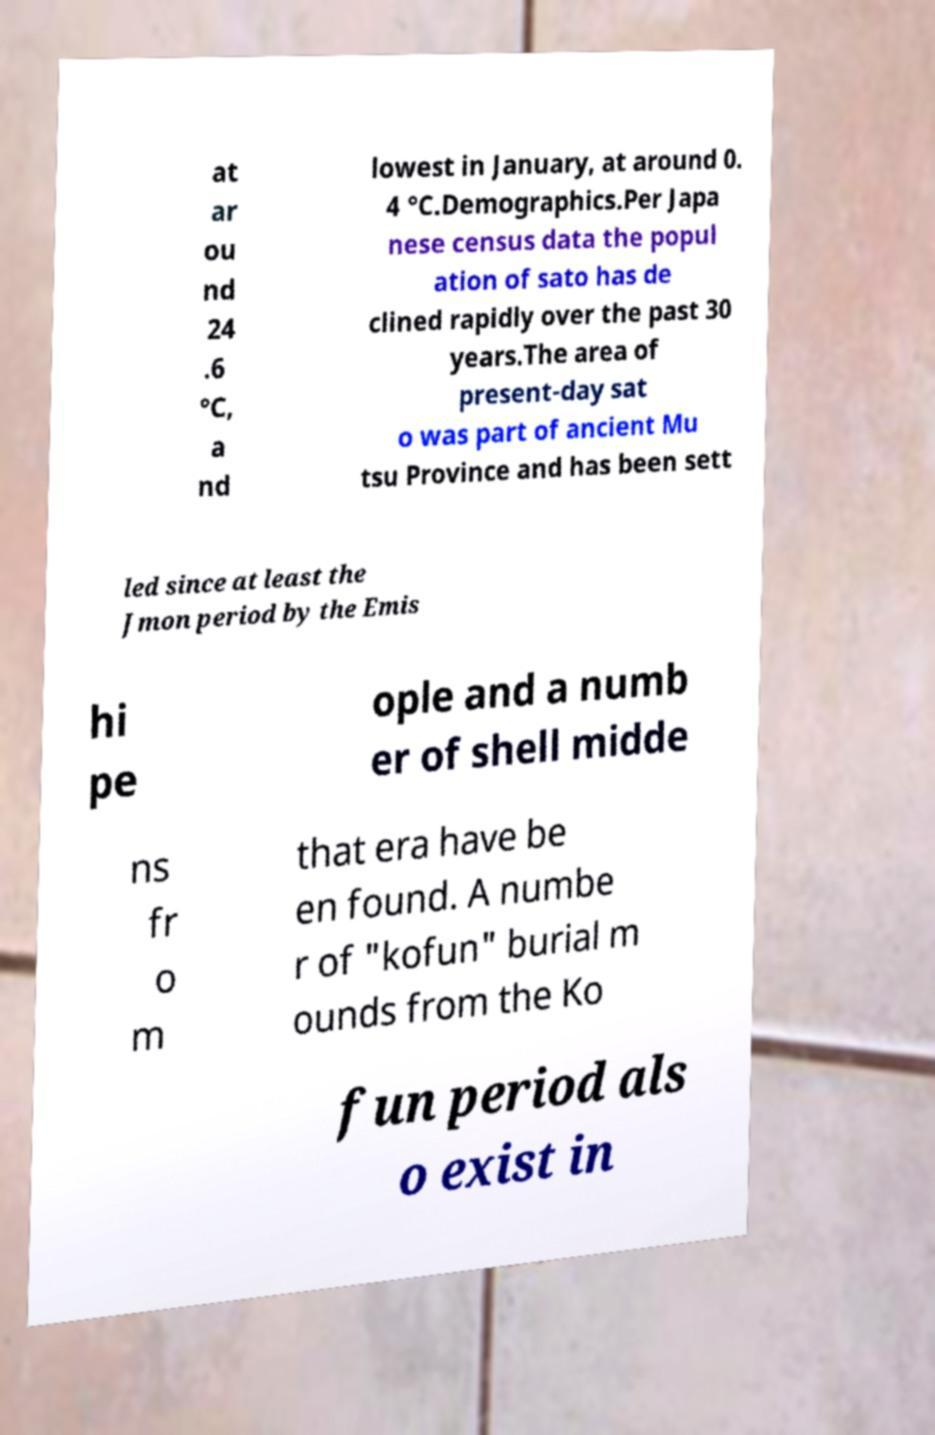What messages or text are displayed in this image? I need them in a readable, typed format. at ar ou nd 24 .6 °C, a nd lowest in January, at around 0. 4 °C.Demographics.Per Japa nese census data the popul ation of sato has de clined rapidly over the past 30 years.The area of present-day sat o was part of ancient Mu tsu Province and has been sett led since at least the Jmon period by the Emis hi pe ople and a numb er of shell midde ns fr o m that era have be en found. A numbe r of "kofun" burial m ounds from the Ko fun period als o exist in 